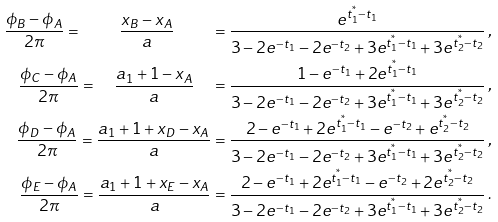Convert formula to latex. <formula><loc_0><loc_0><loc_500><loc_500>\frac { \phi _ { B } - \phi _ { A } } { 2 \pi } = \quad \frac { x _ { B } - x _ { A } } { a } \quad & = \frac { e ^ { t _ { 1 } ^ { ^ { * } } - t _ { 1 } } } { 3 - 2 e ^ { - t _ { 1 } } - 2 e ^ { - t _ { 2 } } + 3 e ^ { t _ { 1 } ^ { ^ { * } } - t _ { 1 } } + 3 e ^ { t _ { 2 } ^ { ^ { * } } - t _ { 2 } } } \, , \\ \frac { \phi _ { C } - \phi _ { A } } { 2 \pi } = \quad \frac { a _ { 1 } + 1 - x _ { A } } { a } \quad & = \frac { 1 - e ^ { - t _ { 1 } } + 2 e ^ { t _ { 1 } ^ { ^ { * } } - t _ { 1 } } } { 3 - 2 e ^ { - t _ { 1 } } - 2 e ^ { - t _ { 2 } } + 3 e ^ { t _ { 1 } ^ { ^ { * } } - t _ { 1 } } + 3 e ^ { t _ { 2 } ^ { ^ { * } } - t _ { 2 } } } \, , \\ \frac { \phi _ { D } - \phi _ { A } } { 2 \pi } = \frac { a _ { 1 } + 1 + x _ { D } - x _ { A } } { a } & = \frac { 2 - e ^ { - t _ { 1 } } + 2 e ^ { t _ { 1 } ^ { ^ { * } } - t _ { 1 } } - e ^ { - t _ { 2 } } + e ^ { t _ { 2 } ^ { ^ { * } } - t _ { 2 } } } { 3 - 2 e ^ { - t _ { 1 } } - 2 e ^ { - t _ { 2 } } + 3 e ^ { t _ { 1 } ^ { ^ { * } } - t _ { 1 } } + 3 e ^ { t _ { 2 } ^ { ^ { * } } - t _ { 2 } } } \, , \\ \frac { \phi _ { E } - \phi _ { A } } { 2 \pi } = \frac { a _ { 1 } + 1 + x _ { E } - x _ { A } } { a } & = \frac { 2 - e ^ { - t _ { 1 } } + 2 e ^ { t _ { 1 } ^ { ^ { * } } - t _ { 1 } } - e ^ { - t _ { 2 } } + 2 e ^ { t _ { 2 } ^ { ^ { * } } - t _ { 2 } } } { 3 - 2 e ^ { - t _ { 1 } } - 2 e ^ { - t _ { 2 } } + 3 e ^ { t _ { 1 } ^ { ^ { * } } - t _ { 1 } } + 3 e ^ { t _ { 2 } ^ { ^ { * } } - t _ { 2 } } } \, .</formula> 